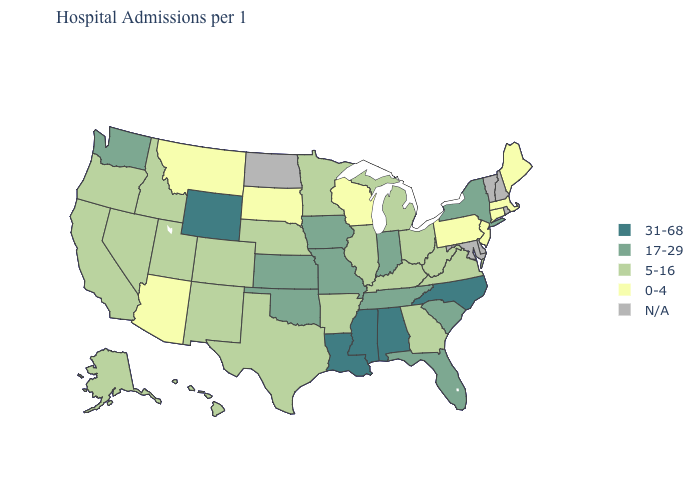What is the lowest value in the USA?
Concise answer only. 0-4. What is the highest value in states that border Minnesota?
Give a very brief answer. 17-29. How many symbols are there in the legend?
Short answer required. 5. What is the highest value in the USA?
Write a very short answer. 31-68. Name the states that have a value in the range 5-16?
Concise answer only. Alaska, Arkansas, California, Colorado, Georgia, Hawaii, Idaho, Illinois, Kentucky, Michigan, Minnesota, Nebraska, Nevada, New Mexico, Ohio, Oregon, Texas, Utah, Virginia, West Virginia. Does Nevada have the lowest value in the West?
Be succinct. No. What is the value of Arkansas?
Quick response, please. 5-16. What is the highest value in states that border North Carolina?
Concise answer only. 17-29. What is the lowest value in states that border Ohio?
Keep it brief. 0-4. Does Alabama have the highest value in the USA?
Be succinct. Yes. Does Arkansas have the lowest value in the South?
Write a very short answer. Yes. What is the lowest value in states that border Arizona?
Be succinct. 5-16. Name the states that have a value in the range 31-68?
Concise answer only. Alabama, Louisiana, Mississippi, North Carolina, Wyoming. Name the states that have a value in the range 0-4?
Give a very brief answer. Arizona, Connecticut, Maine, Massachusetts, Montana, New Jersey, Pennsylvania, South Dakota, Wisconsin. Does North Carolina have the highest value in the USA?
Quick response, please. Yes. 